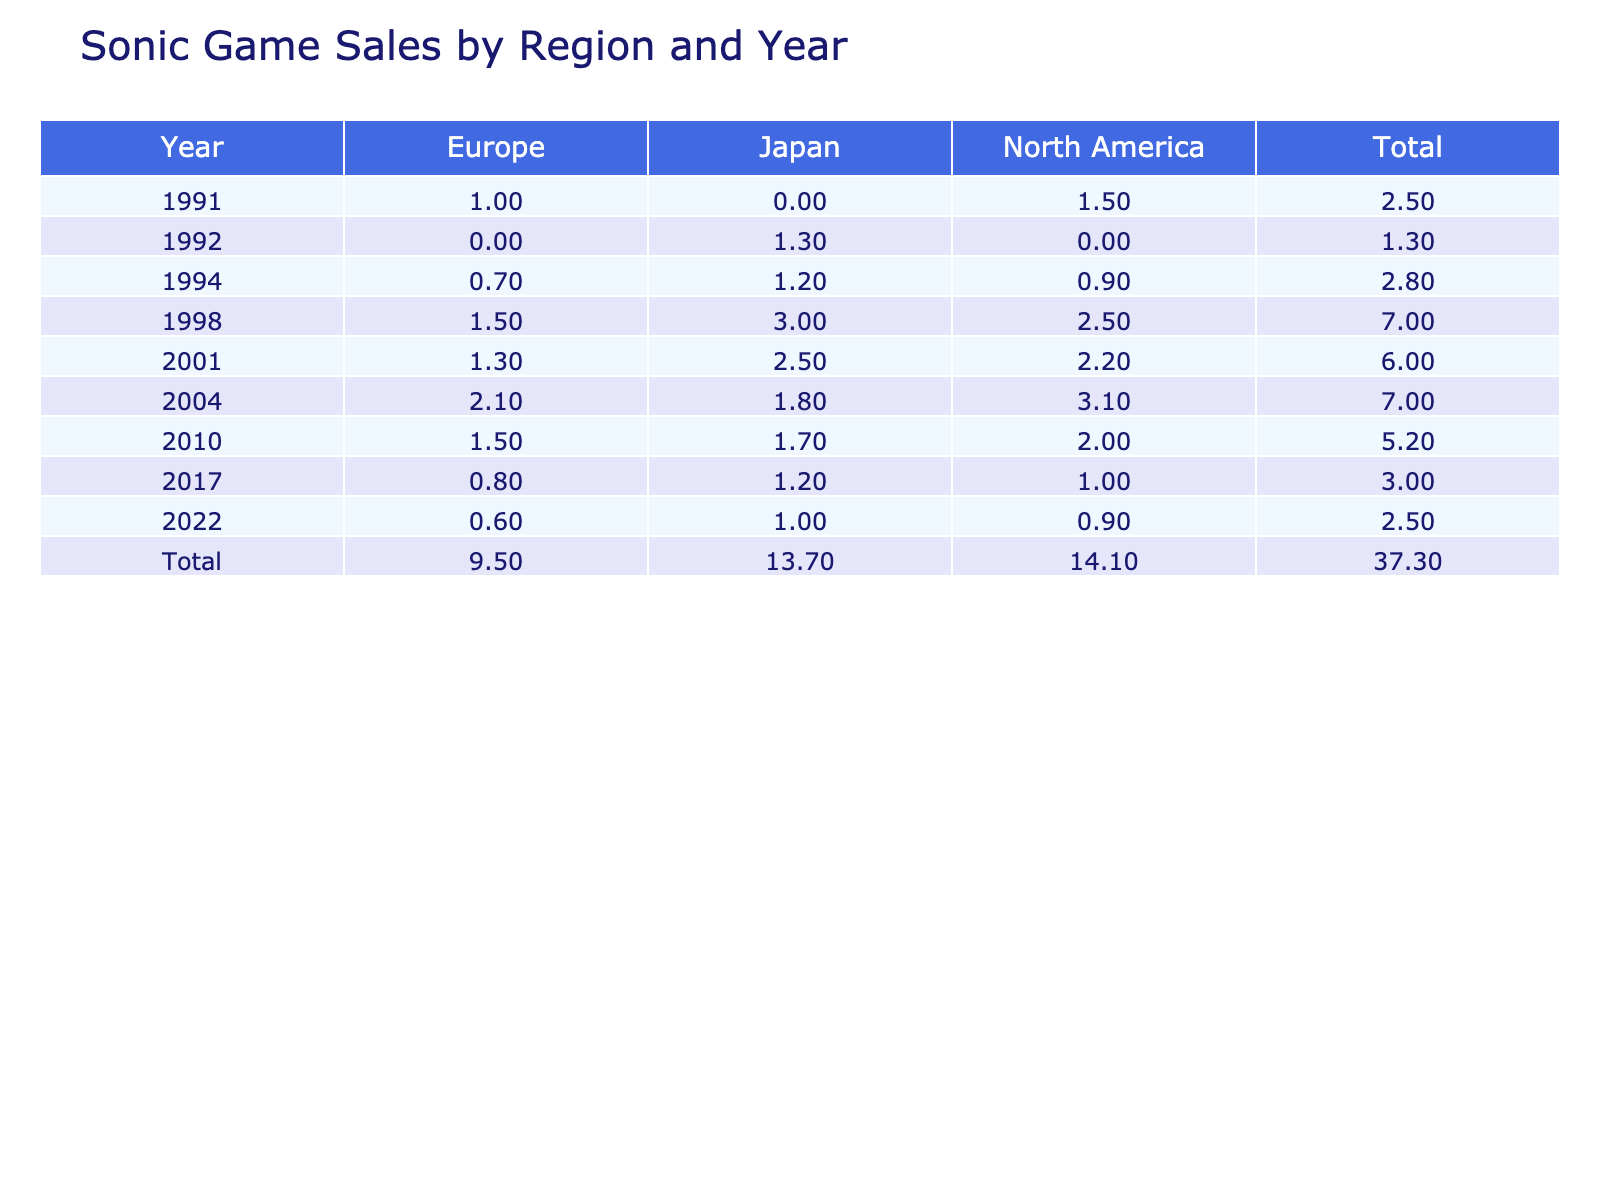What was the total units sold for Sonic Adventure in North America? Looking at the row for Sonic Adventure in North America, it sold 2.5 million units in 1998. This is the only record for this title in that region, so the total is simply 2.5 million.
Answer: 2.5 million Which Sonic game had the highest total sales in Japan? To find the game with the highest sales in Japan, we can check the sales numbers for each title. Sonic Adventure had the highest recorded sales with 3 million units sold in 1998.
Answer: Sonic Adventure What is the average sales for Sonic Colors across all regions? For Sonic Colors, the sales figures are 2.0 million (North America), 1.5 million (Europe), and 1.7 million (Japan). Adding these up gives 2.0 + 1.5 + 1.7 = 5.2 million. We then divide by 3 (the number of regions), which results in an average of 5.2 / 3 = approximately 1.73 million.
Answer: 1.73 million Did Sonic Heroes have higher sales in Europe or Japan? In Europe, Sonic Heroes sold 2.1 million units, while in Japan it sold 1.8 million. By comparing these numbers, we can see that 2.1 million (Europe) is greater than 1.8 million (Japan).
Answer: Yes, Europe In which year did Sonic Franchise achieve the highest total sales across all regions? To determine the year with the highest total sales, we sum the units sold for each year. For 1998, the total is 2.5 + 1.5 + 3.0 = 7.0 million. For 2001, it is 2.2 + 1.3 + 2.5 = 6.0 million. For 2004, the total is 3.1 + 2.1 + 1.8 = 7.0 million. No other year surpasses 7.0 million, so both 1998 and 2004 tie for the highest.
Answer: 1998 and 2004 What percentage of total sales in 2004 were from North America? The total units sold in 2004 are 3.1 (North America) + 2.1 (Europe) + 1.8 (Japan) = 7.0 million. North America’s sales (3.1 million) as a percentage of total sales is (3.1 / 7.0) * 100 = approximately 44.29%.
Answer: 44.29% Which region had the least sales for Sonic Frontiers? For Sonic Frontiers, the sales figures are 0.9 million (North America), 0.6 million (Europe), and 1.0 million (Japan). The lowest value comes from Europe (0.6 million).
Answer: Europe How many more units were sold in Japan for Sonic Adventure 2 compared to Sonic & Knuckles? Sonic Adventure 2 sold 2.5 million units in Japan, and Sonic & Knuckles sold 1.2 million units. The difference is calculated as 2.5 - 1.2 = 1.3 million.
Answer: 1.3 million What is the total sales for Sonic Mania across all regions? Sonic Mania sold 1.0 million in North America, 0.8 million in Europe, and 1.2 million in Japan. Adding these amounts gives us 1.0 + 0.8 + 1.2 = 3.0 million.
Answer: 3.0 million 